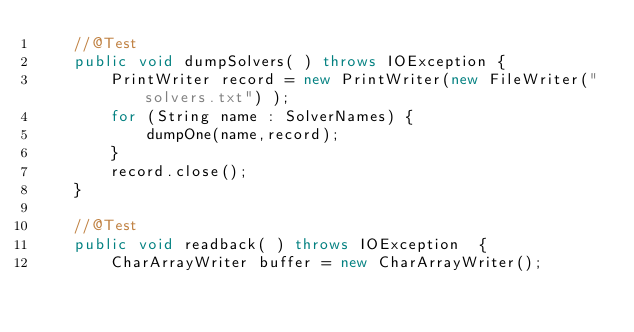<code> <loc_0><loc_0><loc_500><loc_500><_Java_>	//@Test
	public void dumpSolvers( ) throws IOException {
		PrintWriter record = new PrintWriter(new FileWriter("solvers.txt") );
		for (String name : SolverNames) {
			dumpOne(name,record);
		}
		record.close();
	}
	
	//@Test
	public void readback( ) throws IOException  {
		CharArrayWriter buffer = new CharArrayWriter();</code> 